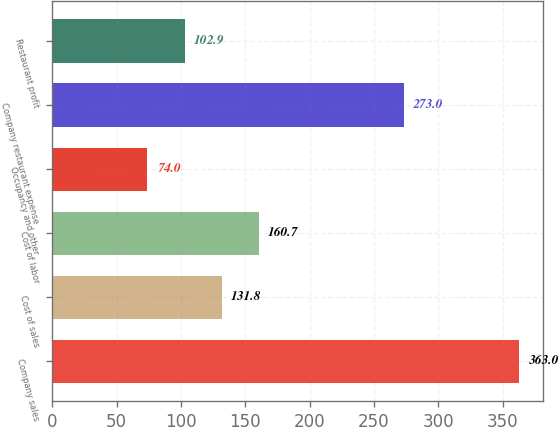Convert chart. <chart><loc_0><loc_0><loc_500><loc_500><bar_chart><fcel>Company sales<fcel>Cost of sales<fcel>Cost of labor<fcel>Occupancy and other<fcel>Company restaurant expense<fcel>Restaurant profit<nl><fcel>363<fcel>131.8<fcel>160.7<fcel>74<fcel>273<fcel>102.9<nl></chart> 